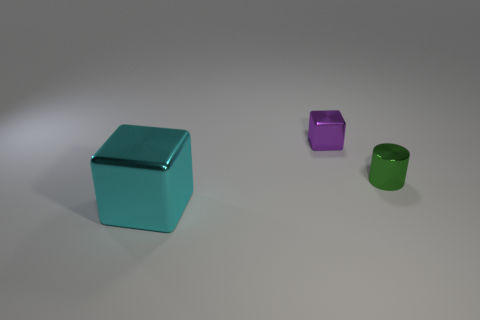Subtract all purple blocks. How many blocks are left? 1 Add 2 tiny green metallic cylinders. How many objects exist? 5 Subtract 1 cylinders. How many cylinders are left? 0 Subtract 0 brown balls. How many objects are left? 3 Subtract all cubes. How many objects are left? 1 Subtract all yellow cubes. Subtract all brown spheres. How many cubes are left? 2 Subtract all yellow cylinders. How many cyan cubes are left? 1 Subtract all cyan metallic cubes. Subtract all tiny yellow blocks. How many objects are left? 2 Add 1 shiny cubes. How many shiny cubes are left? 3 Add 1 shiny balls. How many shiny balls exist? 1 